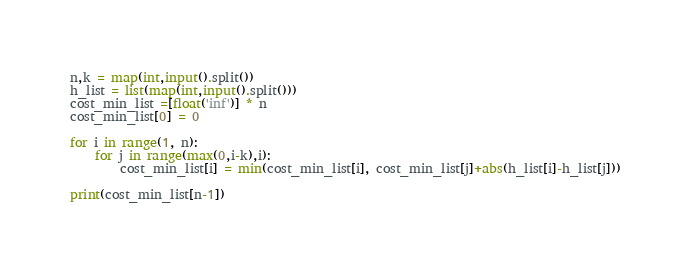<code> <loc_0><loc_0><loc_500><loc_500><_Python_>n,k = map(int,input().split())
h_list = list(map(int,input().split()))
cost_min_list =[float('inf')] * n
cost_min_list[0] = 0

for i in range(1, n):
    for j in range(max(0,i-k),i):
        cost_min_list[i] = min(cost_min_list[i], cost_min_list[j]+abs(h_list[i]-h_list[j]))

print(cost_min_list[n-1])</code> 